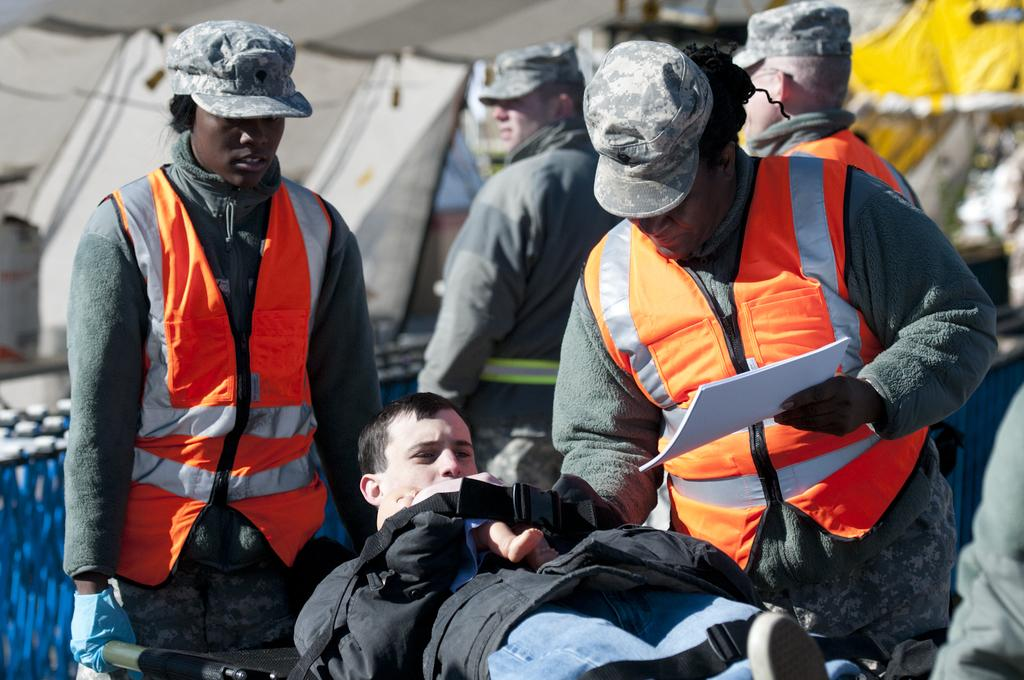What are the two persons in the image doing? The two persons are carrying a person on a stretcher. Are there any other people in the image? Yes, there are two other persons behind them. What can be seen in the background of the image? There are tents in the image. Can you tell me how many toes the person on the stretcher has? There is no information about the person's toes in the image, as the focus is on the stretcher and the people carrying it. 